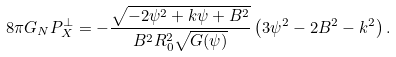<formula> <loc_0><loc_0><loc_500><loc_500>8 \pi G _ { N } P _ { X } ^ { \bot } = - \frac { \sqrt { - 2 \psi ^ { 2 } + k \psi + B ^ { 2 } } } { B ^ { 2 } R _ { 0 } ^ { 2 } \sqrt { G ( \psi ) } } \left ( 3 \psi ^ { 2 } - 2 B ^ { 2 } - k ^ { 2 } \right ) .</formula> 